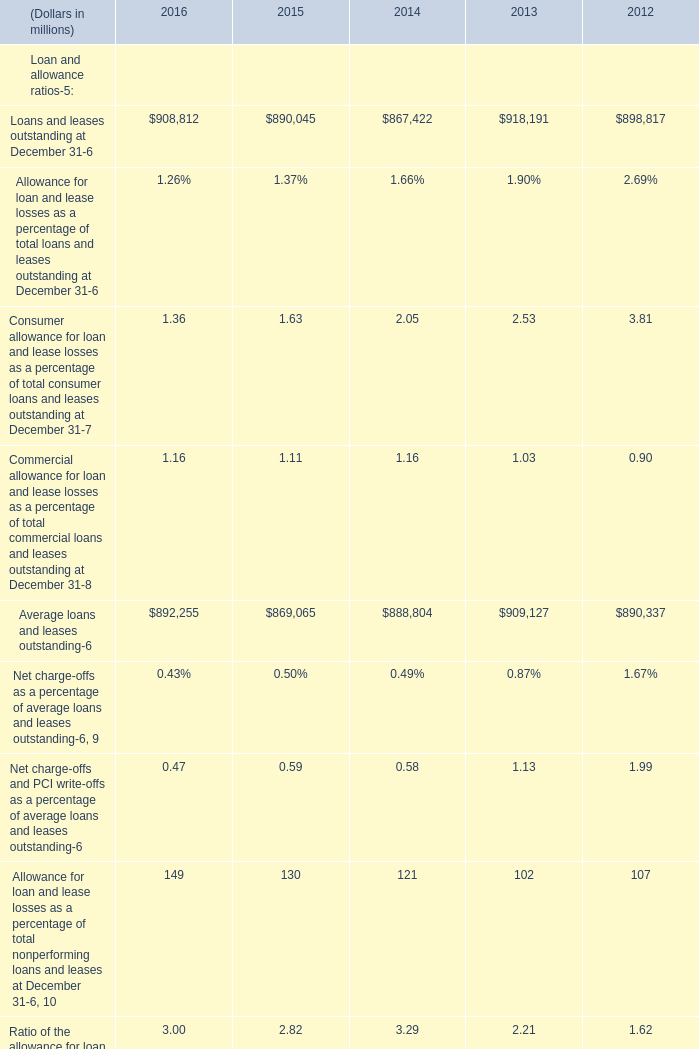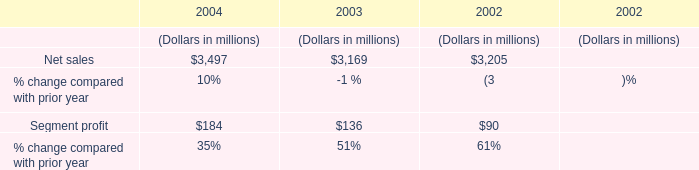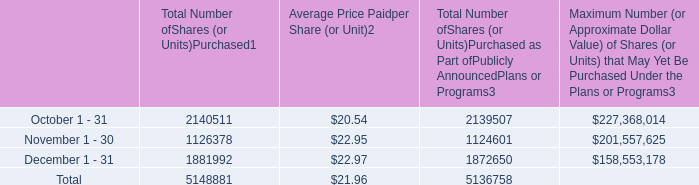What will Loans and leases outstanding at December 31 be like in 2017 if it continues to grow at the same rate as it did in 2016? (in million) 
Computations: (908812 * (1 + ((908812 - 890045) / 890045)))
Answer: 927974.71065. 